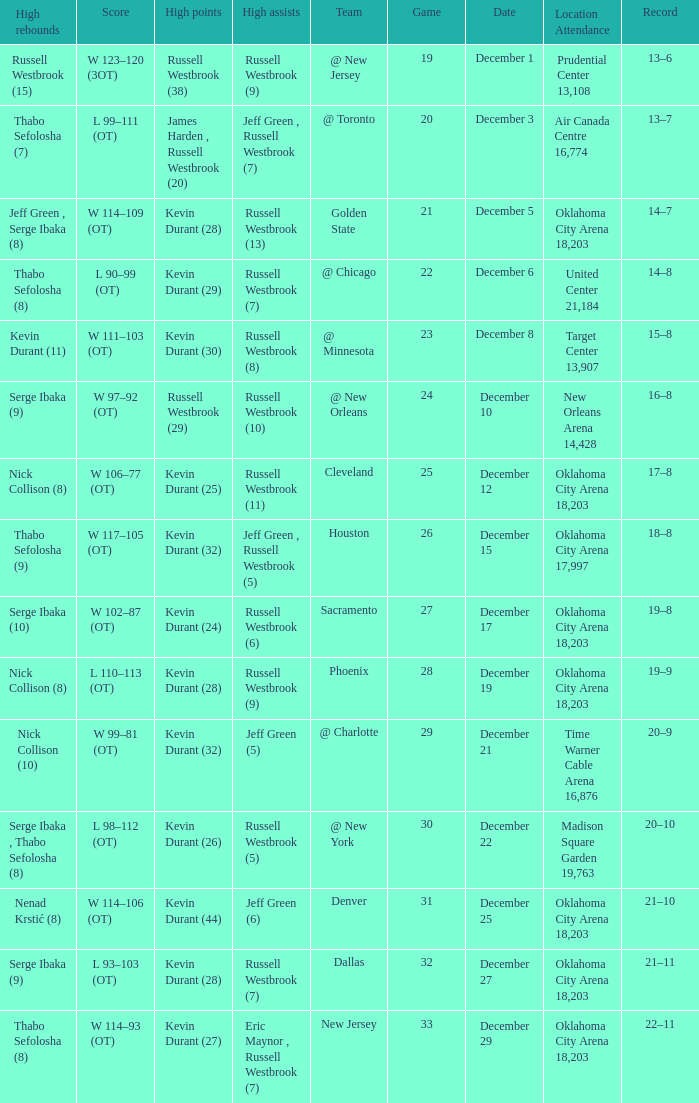Who had the high rebounds record on December 12? Nick Collison (8). 